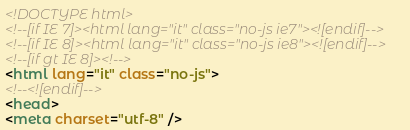Convert code to text. <code><loc_0><loc_0><loc_500><loc_500><_HTML_><!DOCTYPE html>
<!--[if IE 7]><html lang="it" class="no-js ie7"><![endif]-->
<!--[if IE 8]><html lang="it" class="no-js ie8"><![endif]-->
<!--[if gt IE 8]><!-->
<html lang="it" class="no-js">
<!--<![endif]-->
<head>
<meta charset="utf-8" /></code> 